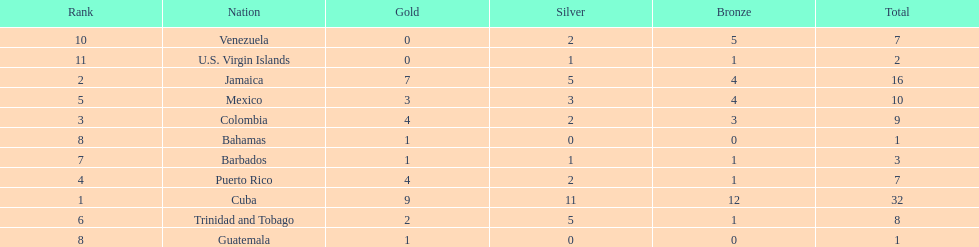What is the difference in medals between cuba and mexico? 22. 